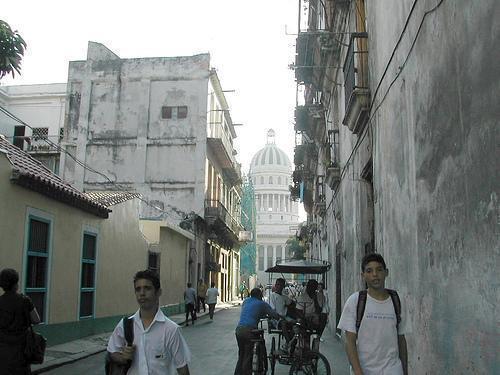Who is closest to the wall?
Choose the right answer from the provided options to respond to the question.
Options: Boy, old woman, old man, young girl. Boy. 